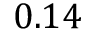Convert formula to latex. <formula><loc_0><loc_0><loc_500><loc_500>0 . 1 4</formula> 